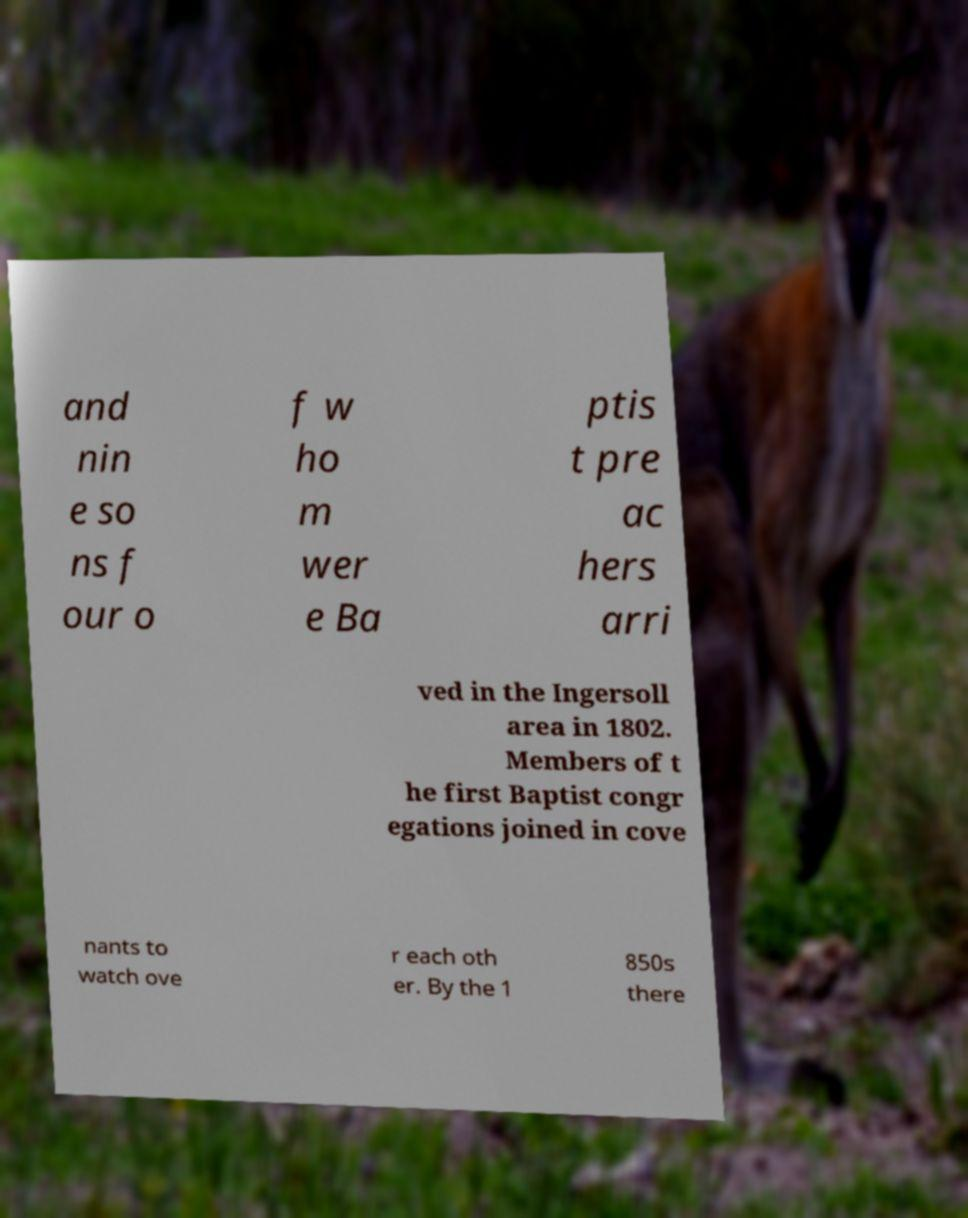Can you read and provide the text displayed in the image?This photo seems to have some interesting text. Can you extract and type it out for me? and nin e so ns f our o f w ho m wer e Ba ptis t pre ac hers arri ved in the Ingersoll area in 1802. Members of t he first Baptist congr egations joined in cove nants to watch ove r each oth er. By the 1 850s there 